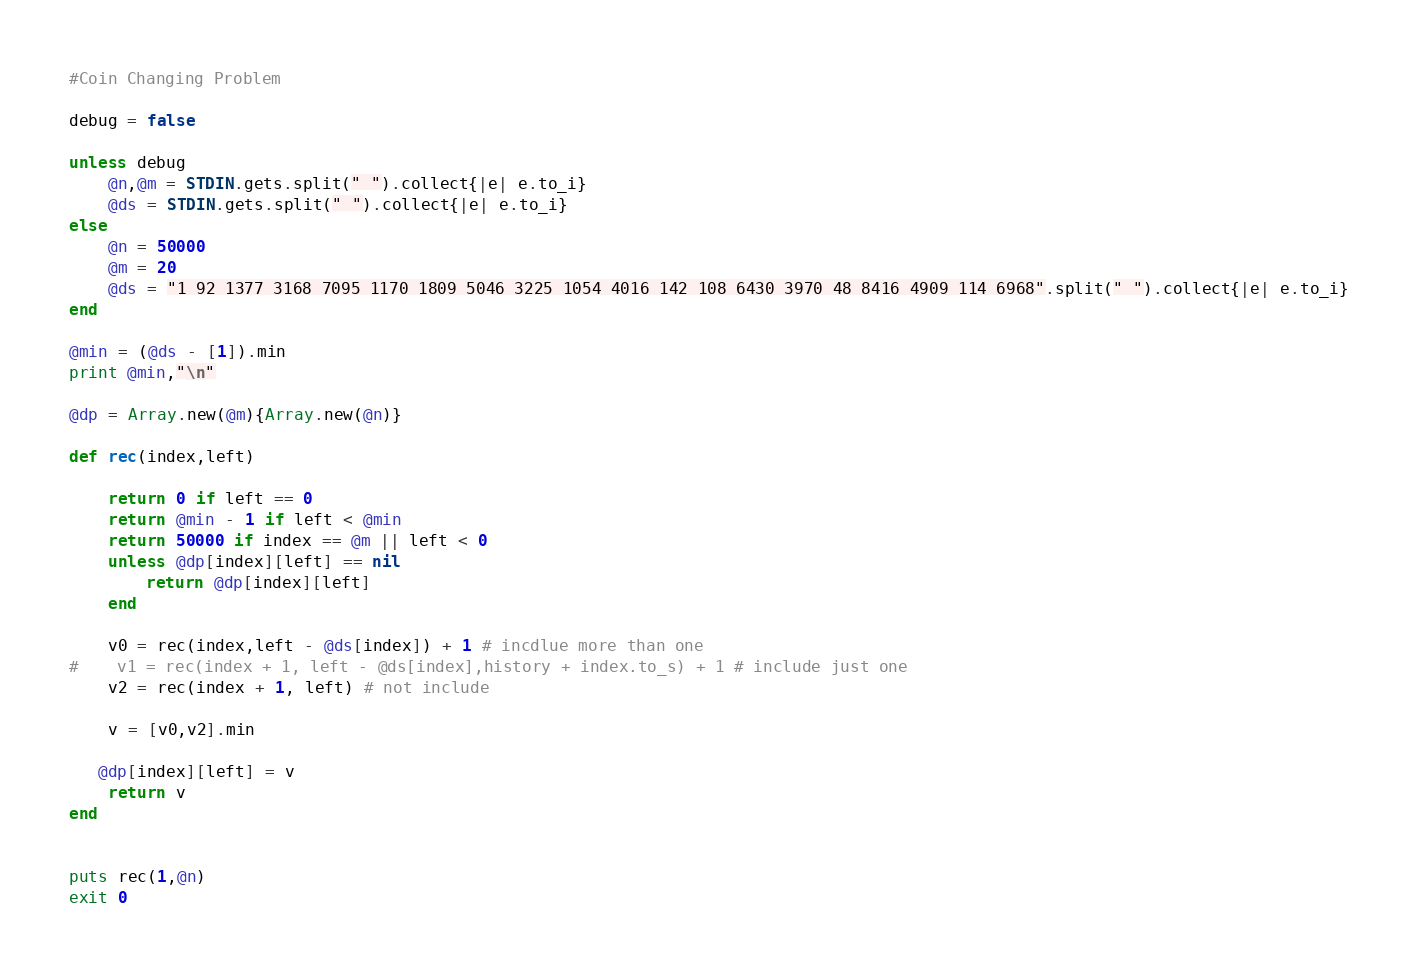<code> <loc_0><loc_0><loc_500><loc_500><_Ruby_>#Coin Changing Problem

debug = false

unless debug
    @n,@m = STDIN.gets.split(" ").collect{|e| e.to_i}
    @ds = STDIN.gets.split(" ").collect{|e| e.to_i}
else
    @n = 50000
    @m = 20
    @ds = "1 92 1377 3168 7095 1170 1809 5046 3225 1054 4016 142 108 6430 3970 48 8416 4909 114 6968".split(" ").collect{|e| e.to_i}
end

@min = (@ds - [1]).min
print @min,"\n"

@dp = Array.new(@m){Array.new(@n)}

def rec(index,left)

    return 0 if left == 0
    return @min - 1 if left < @min
    return 50000 if index == @m || left < 0
    unless @dp[index][left] == nil
        return @dp[index][left]         
    end

    v0 = rec(index,left - @ds[index]) + 1 # incdlue more than one
#    v1 = rec(index + 1, left - @ds[index],history + index.to_s) + 1 # include just one
    v2 = rec(index + 1, left) # not include

    v = [v0,v2].min

   @dp[index][left] = v
    return v
end


puts rec(1,@n)
exit 0</code> 